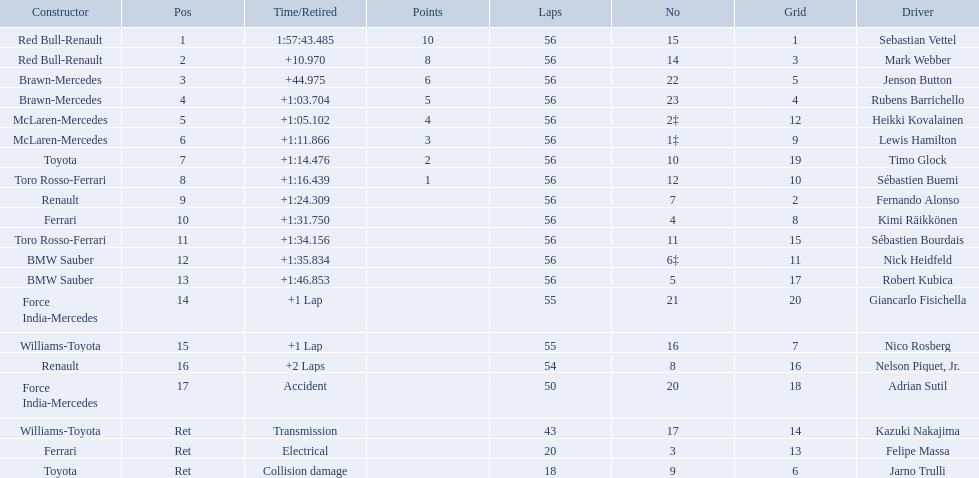Which drivers raced in the 2009 chinese grand prix? Sebastian Vettel, Mark Webber, Jenson Button, Rubens Barrichello, Heikki Kovalainen, Lewis Hamilton, Timo Glock, Sébastien Buemi, Fernando Alonso, Kimi Räikkönen, Sébastien Bourdais, Nick Heidfeld, Robert Kubica, Giancarlo Fisichella, Nico Rosberg, Nelson Piquet, Jr., Adrian Sutil, Kazuki Nakajima, Felipe Massa, Jarno Trulli. Of the drivers in the 2009 chinese grand prix, which finished the race? Sebastian Vettel, Mark Webber, Jenson Button, Rubens Barrichello, Heikki Kovalainen, Lewis Hamilton, Timo Glock, Sébastien Buemi, Fernando Alonso, Kimi Räikkönen, Sébastien Bourdais, Nick Heidfeld, Robert Kubica. Of the drivers who finished the race, who had the slowest time? Robert Kubica. Which drivers took part in the 2009 chinese grand prix? Sebastian Vettel, Mark Webber, Jenson Button, Rubens Barrichello, Heikki Kovalainen, Lewis Hamilton, Timo Glock, Sébastien Buemi, Fernando Alonso, Kimi Räikkönen, Sébastien Bourdais, Nick Heidfeld, Robert Kubica, Giancarlo Fisichella, Nico Rosberg, Nelson Piquet, Jr., Adrian Sutil, Kazuki Nakajima, Felipe Massa, Jarno Trulli. Of these, who completed all 56 laps? Sebastian Vettel, Mark Webber, Jenson Button, Rubens Barrichello, Heikki Kovalainen, Lewis Hamilton, Timo Glock, Sébastien Buemi, Fernando Alonso, Kimi Räikkönen, Sébastien Bourdais, Nick Heidfeld, Robert Kubica. Of these, which did ferrari not participate as a constructor? Sebastian Vettel, Mark Webber, Jenson Button, Rubens Barrichello, Heikki Kovalainen, Lewis Hamilton, Timo Glock, Fernando Alonso, Kimi Räikkönen, Nick Heidfeld, Robert Kubica. Of the remaining, which is in pos 1? Sebastian Vettel. 